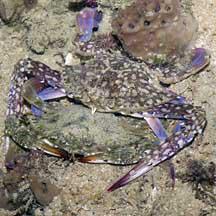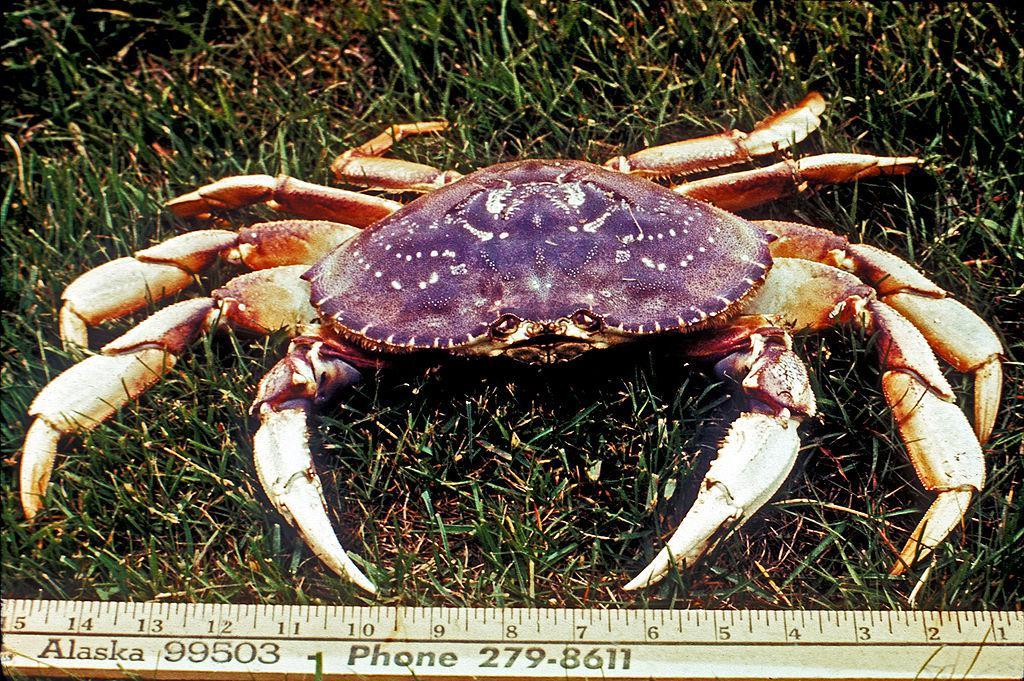The first image is the image on the left, the second image is the image on the right. For the images displayed, is the sentence "One crab is standing up tall on the sand." factually correct? Answer yes or no. No. 